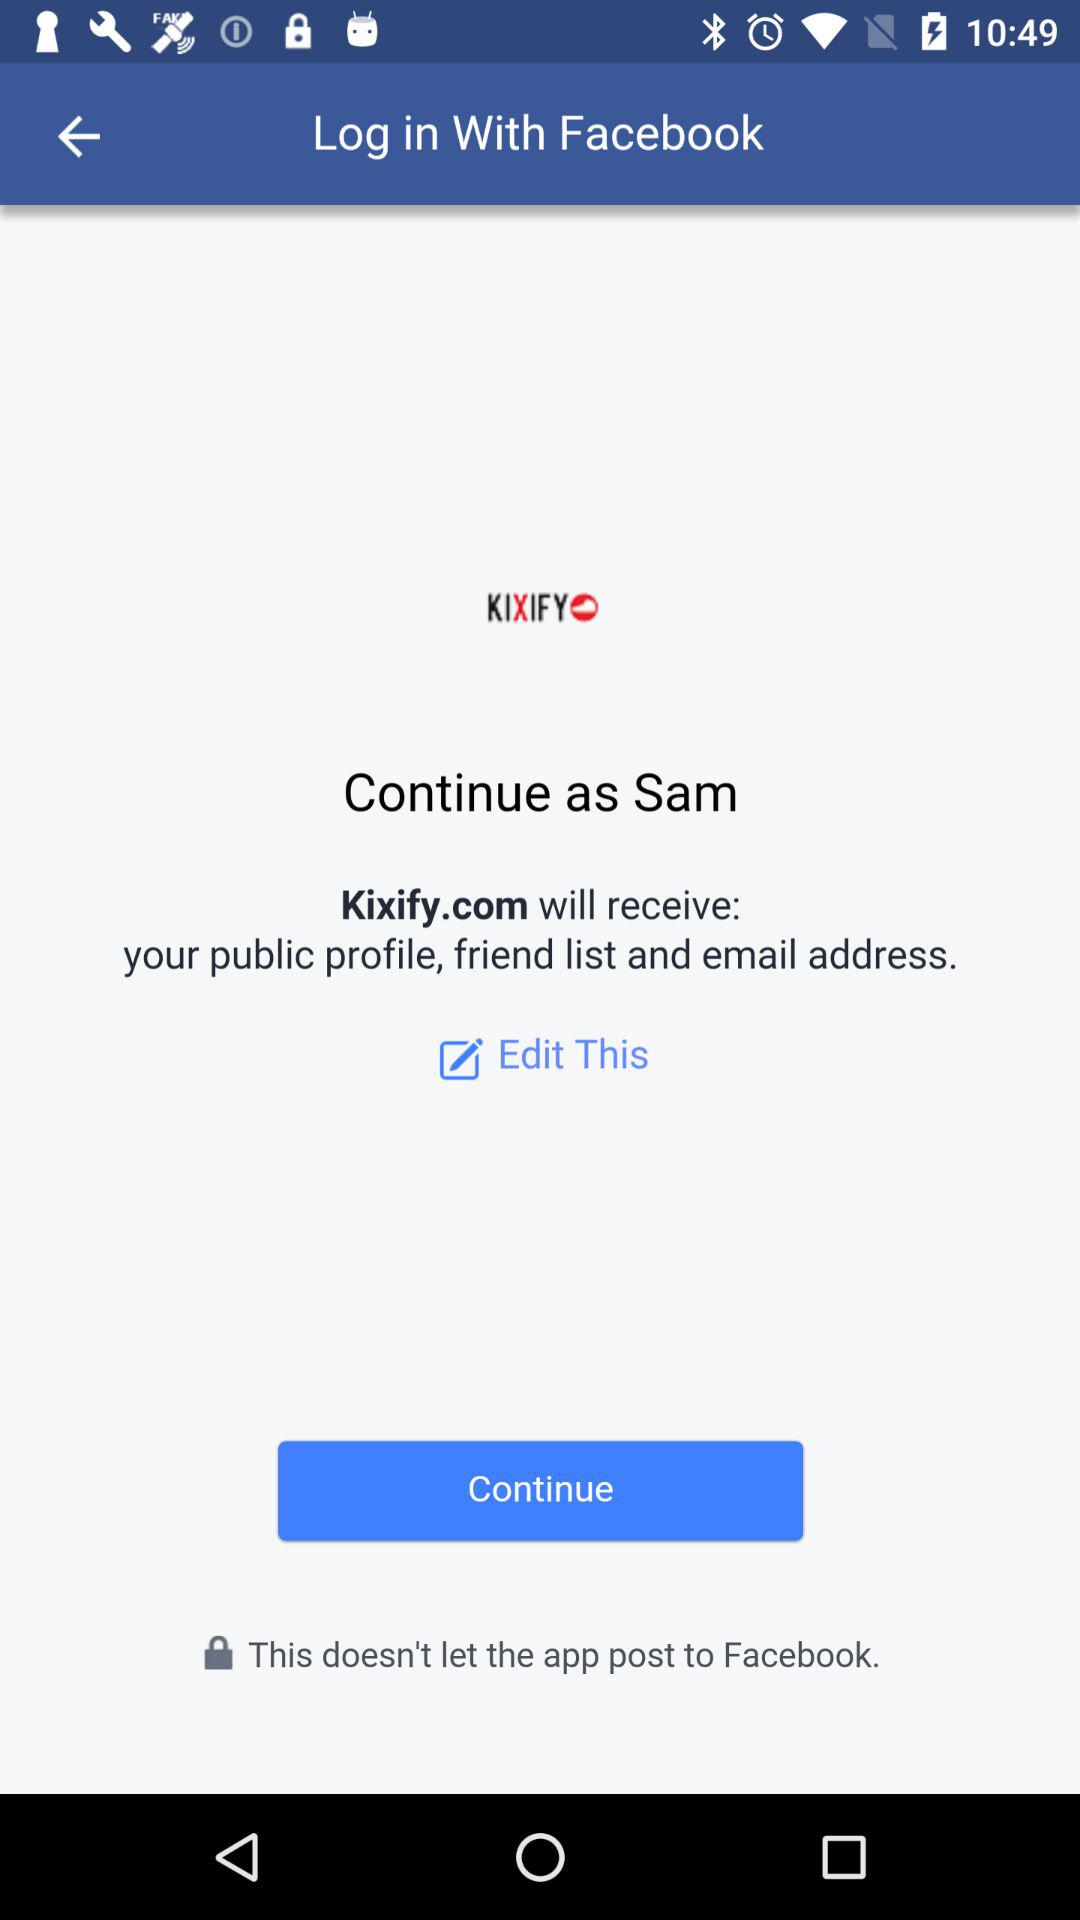What's the user name by which the application can be continued? The user name is Sam. 